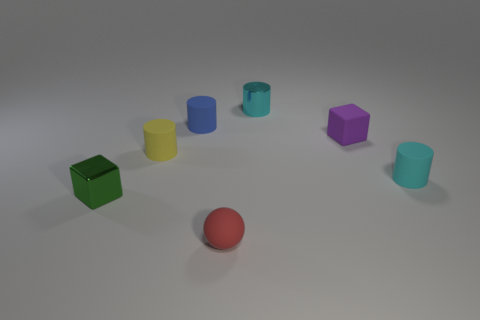Add 3 cylinders. How many objects exist? 10 Subtract all spheres. How many objects are left? 6 Add 2 small yellow things. How many small yellow things are left? 3 Add 6 big gray metallic cylinders. How many big gray metallic cylinders exist? 6 Subtract 0 brown cubes. How many objects are left? 7 Subtract all big purple cylinders. Subtract all small rubber cylinders. How many objects are left? 4 